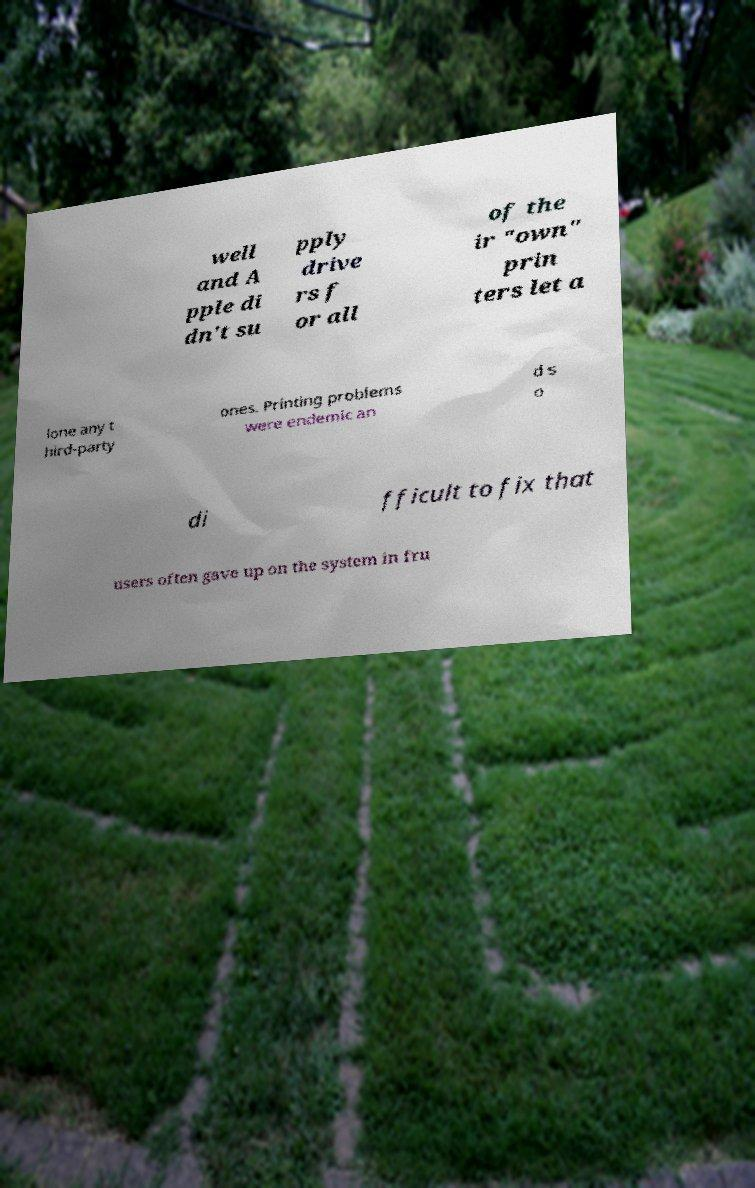Could you extract and type out the text from this image? well and A pple di dn't su pply drive rs f or all of the ir "own" prin ters let a lone any t hird-party ones. Printing problems were endemic an d s o di fficult to fix that users often gave up on the system in fru 